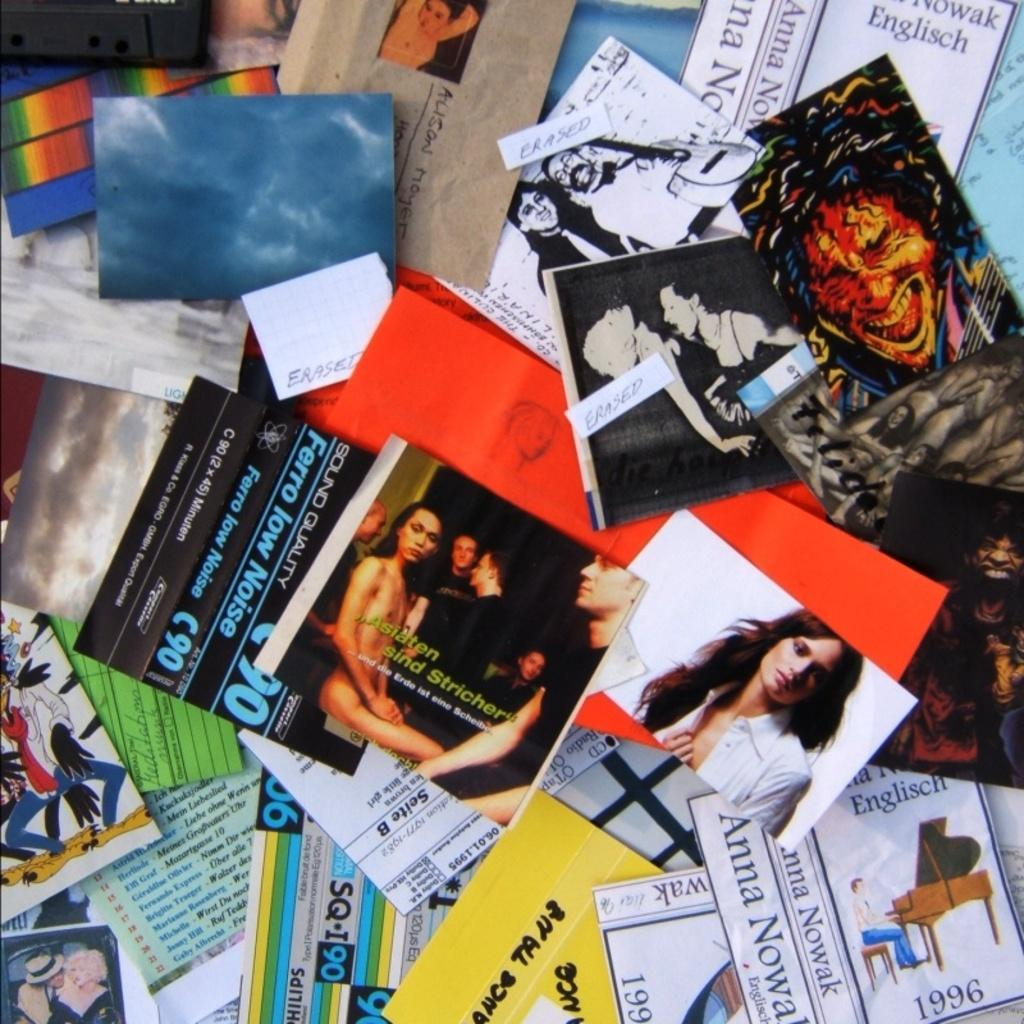<image>
Render a clear and concise summary of the photo. Photo of a naked person with the words "Asiaten sind Stricher" on it. 